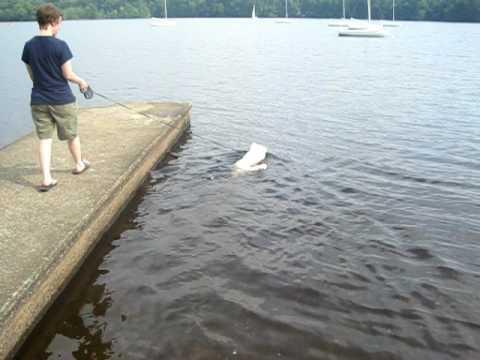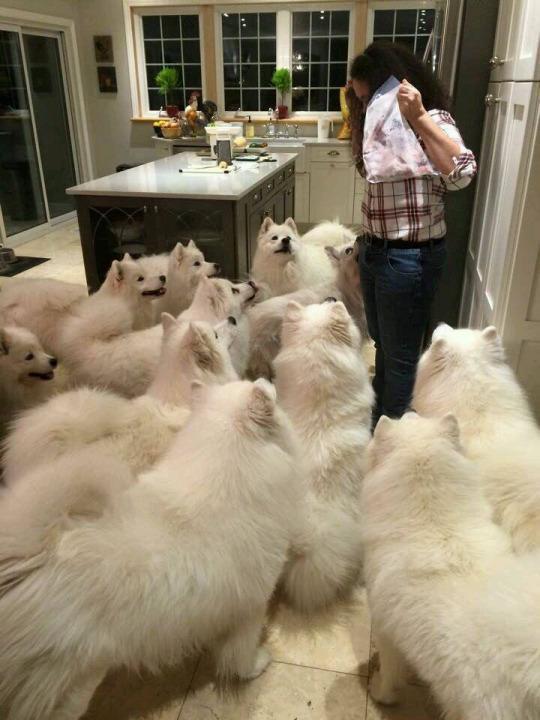The first image is the image on the left, the second image is the image on the right. Analyze the images presented: Is the assertion "In at least one image, a white dog is seen swimming in water" valid? Answer yes or no. Yes. The first image is the image on the left, the second image is the image on the right. Given the left and right images, does the statement "The left image contains a white dog swimming in water." hold true? Answer yes or no. Yes. 